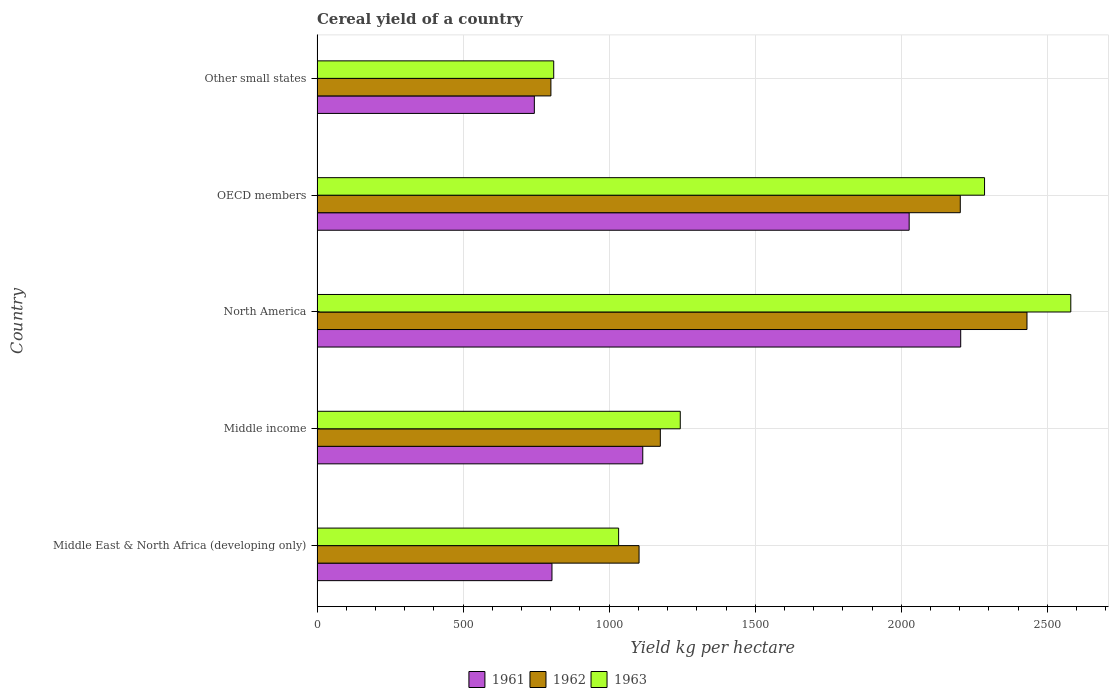How many different coloured bars are there?
Your answer should be compact. 3. How many groups of bars are there?
Your answer should be very brief. 5. Are the number of bars per tick equal to the number of legend labels?
Keep it short and to the point. Yes. Are the number of bars on each tick of the Y-axis equal?
Give a very brief answer. Yes. How many bars are there on the 2nd tick from the top?
Give a very brief answer. 3. How many bars are there on the 2nd tick from the bottom?
Your answer should be compact. 3. What is the total cereal yield in 1962 in Middle income?
Make the answer very short. 1175.1. Across all countries, what is the maximum total cereal yield in 1961?
Give a very brief answer. 2203.29. Across all countries, what is the minimum total cereal yield in 1962?
Provide a succinct answer. 800.53. In which country was the total cereal yield in 1962 maximum?
Offer a terse response. North America. In which country was the total cereal yield in 1961 minimum?
Make the answer very short. Other small states. What is the total total cereal yield in 1963 in the graph?
Your response must be concise. 7950.86. What is the difference between the total cereal yield in 1963 in Middle East & North Africa (developing only) and that in North America?
Ensure brevity in your answer.  -1547.89. What is the difference between the total cereal yield in 1963 in Other small states and the total cereal yield in 1961 in OECD members?
Your answer should be very brief. -1216.76. What is the average total cereal yield in 1963 per country?
Provide a short and direct response. 1590.17. What is the difference between the total cereal yield in 1962 and total cereal yield in 1961 in Other small states?
Provide a short and direct response. 56.73. What is the ratio of the total cereal yield in 1962 in Middle income to that in OECD members?
Give a very brief answer. 0.53. Is the total cereal yield in 1961 in OECD members less than that in Other small states?
Make the answer very short. No. What is the difference between the highest and the second highest total cereal yield in 1963?
Offer a very short reply. 295.28. What is the difference between the highest and the lowest total cereal yield in 1962?
Your answer should be compact. 1629.69. How many bars are there?
Make the answer very short. 15. Are all the bars in the graph horizontal?
Keep it short and to the point. Yes. How many countries are there in the graph?
Provide a succinct answer. 5. What is the difference between two consecutive major ticks on the X-axis?
Your answer should be very brief. 500. Are the values on the major ticks of X-axis written in scientific E-notation?
Ensure brevity in your answer.  No. How many legend labels are there?
Your answer should be compact. 3. How are the legend labels stacked?
Your answer should be very brief. Horizontal. What is the title of the graph?
Give a very brief answer. Cereal yield of a country. What is the label or title of the X-axis?
Your response must be concise. Yield kg per hectare. What is the Yield kg per hectare in 1961 in Middle East & North Africa (developing only)?
Provide a short and direct response. 804.16. What is the Yield kg per hectare of 1962 in Middle East & North Africa (developing only)?
Provide a short and direct response. 1102.28. What is the Yield kg per hectare of 1963 in Middle East & North Africa (developing only)?
Make the answer very short. 1032.31. What is the Yield kg per hectare of 1961 in Middle income?
Offer a very short reply. 1114.95. What is the Yield kg per hectare in 1962 in Middle income?
Your response must be concise. 1175.1. What is the Yield kg per hectare in 1963 in Middle income?
Provide a succinct answer. 1243.31. What is the Yield kg per hectare of 1961 in North America?
Your answer should be very brief. 2203.29. What is the Yield kg per hectare of 1962 in North America?
Offer a terse response. 2430.22. What is the Yield kg per hectare in 1963 in North America?
Make the answer very short. 2580.19. What is the Yield kg per hectare of 1961 in OECD members?
Keep it short and to the point. 2026.89. What is the Yield kg per hectare of 1962 in OECD members?
Give a very brief answer. 2201.88. What is the Yield kg per hectare in 1963 in OECD members?
Ensure brevity in your answer.  2284.91. What is the Yield kg per hectare in 1961 in Other small states?
Your answer should be very brief. 743.8. What is the Yield kg per hectare of 1962 in Other small states?
Your answer should be very brief. 800.53. What is the Yield kg per hectare in 1963 in Other small states?
Offer a very short reply. 810.13. Across all countries, what is the maximum Yield kg per hectare of 1961?
Offer a terse response. 2203.29. Across all countries, what is the maximum Yield kg per hectare in 1962?
Make the answer very short. 2430.22. Across all countries, what is the maximum Yield kg per hectare in 1963?
Your response must be concise. 2580.19. Across all countries, what is the minimum Yield kg per hectare in 1961?
Give a very brief answer. 743.8. Across all countries, what is the minimum Yield kg per hectare of 1962?
Give a very brief answer. 800.53. Across all countries, what is the minimum Yield kg per hectare of 1963?
Your response must be concise. 810.13. What is the total Yield kg per hectare of 1961 in the graph?
Keep it short and to the point. 6893.09. What is the total Yield kg per hectare of 1962 in the graph?
Ensure brevity in your answer.  7710.01. What is the total Yield kg per hectare of 1963 in the graph?
Ensure brevity in your answer.  7950.86. What is the difference between the Yield kg per hectare in 1961 in Middle East & North Africa (developing only) and that in Middle income?
Offer a terse response. -310.79. What is the difference between the Yield kg per hectare in 1962 in Middle East & North Africa (developing only) and that in Middle income?
Provide a succinct answer. -72.82. What is the difference between the Yield kg per hectare in 1963 in Middle East & North Africa (developing only) and that in Middle income?
Provide a short and direct response. -211. What is the difference between the Yield kg per hectare in 1961 in Middle East & North Africa (developing only) and that in North America?
Your response must be concise. -1399.14. What is the difference between the Yield kg per hectare of 1962 in Middle East & North Africa (developing only) and that in North America?
Your response must be concise. -1327.94. What is the difference between the Yield kg per hectare in 1963 in Middle East & North Africa (developing only) and that in North America?
Your answer should be compact. -1547.89. What is the difference between the Yield kg per hectare of 1961 in Middle East & North Africa (developing only) and that in OECD members?
Your answer should be very brief. -1222.73. What is the difference between the Yield kg per hectare of 1962 in Middle East & North Africa (developing only) and that in OECD members?
Ensure brevity in your answer.  -1099.6. What is the difference between the Yield kg per hectare of 1963 in Middle East & North Africa (developing only) and that in OECD members?
Your answer should be compact. -1252.61. What is the difference between the Yield kg per hectare in 1961 in Middle East & North Africa (developing only) and that in Other small states?
Make the answer very short. 60.36. What is the difference between the Yield kg per hectare in 1962 in Middle East & North Africa (developing only) and that in Other small states?
Your answer should be very brief. 301.75. What is the difference between the Yield kg per hectare of 1963 in Middle East & North Africa (developing only) and that in Other small states?
Ensure brevity in your answer.  222.18. What is the difference between the Yield kg per hectare of 1961 in Middle income and that in North America?
Make the answer very short. -1088.35. What is the difference between the Yield kg per hectare of 1962 in Middle income and that in North America?
Your answer should be compact. -1255.12. What is the difference between the Yield kg per hectare in 1963 in Middle income and that in North America?
Give a very brief answer. -1336.88. What is the difference between the Yield kg per hectare of 1961 in Middle income and that in OECD members?
Offer a terse response. -911.94. What is the difference between the Yield kg per hectare in 1962 in Middle income and that in OECD members?
Make the answer very short. -1026.78. What is the difference between the Yield kg per hectare of 1963 in Middle income and that in OECD members?
Your answer should be compact. -1041.6. What is the difference between the Yield kg per hectare in 1961 in Middle income and that in Other small states?
Your response must be concise. 371.14. What is the difference between the Yield kg per hectare in 1962 in Middle income and that in Other small states?
Your answer should be very brief. 374.57. What is the difference between the Yield kg per hectare in 1963 in Middle income and that in Other small states?
Offer a very short reply. 433.18. What is the difference between the Yield kg per hectare in 1961 in North America and that in OECD members?
Keep it short and to the point. 176.41. What is the difference between the Yield kg per hectare of 1962 in North America and that in OECD members?
Provide a succinct answer. 228.34. What is the difference between the Yield kg per hectare in 1963 in North America and that in OECD members?
Ensure brevity in your answer.  295.28. What is the difference between the Yield kg per hectare of 1961 in North America and that in Other small states?
Your response must be concise. 1459.49. What is the difference between the Yield kg per hectare of 1962 in North America and that in Other small states?
Provide a succinct answer. 1629.69. What is the difference between the Yield kg per hectare in 1963 in North America and that in Other small states?
Your answer should be compact. 1770.06. What is the difference between the Yield kg per hectare in 1961 in OECD members and that in Other small states?
Make the answer very short. 1283.09. What is the difference between the Yield kg per hectare in 1962 in OECD members and that in Other small states?
Your response must be concise. 1401.35. What is the difference between the Yield kg per hectare of 1963 in OECD members and that in Other small states?
Offer a very short reply. 1474.78. What is the difference between the Yield kg per hectare in 1961 in Middle East & North Africa (developing only) and the Yield kg per hectare in 1962 in Middle income?
Provide a succinct answer. -370.94. What is the difference between the Yield kg per hectare of 1961 in Middle East & North Africa (developing only) and the Yield kg per hectare of 1963 in Middle income?
Ensure brevity in your answer.  -439.15. What is the difference between the Yield kg per hectare in 1962 in Middle East & North Africa (developing only) and the Yield kg per hectare in 1963 in Middle income?
Your answer should be compact. -141.03. What is the difference between the Yield kg per hectare of 1961 in Middle East & North Africa (developing only) and the Yield kg per hectare of 1962 in North America?
Provide a succinct answer. -1626.06. What is the difference between the Yield kg per hectare in 1961 in Middle East & North Africa (developing only) and the Yield kg per hectare in 1963 in North America?
Offer a terse response. -1776.04. What is the difference between the Yield kg per hectare in 1962 in Middle East & North Africa (developing only) and the Yield kg per hectare in 1963 in North America?
Your answer should be compact. -1477.91. What is the difference between the Yield kg per hectare of 1961 in Middle East & North Africa (developing only) and the Yield kg per hectare of 1962 in OECD members?
Offer a terse response. -1397.72. What is the difference between the Yield kg per hectare of 1961 in Middle East & North Africa (developing only) and the Yield kg per hectare of 1963 in OECD members?
Give a very brief answer. -1480.76. What is the difference between the Yield kg per hectare in 1962 in Middle East & North Africa (developing only) and the Yield kg per hectare in 1963 in OECD members?
Offer a very short reply. -1182.63. What is the difference between the Yield kg per hectare in 1961 in Middle East & North Africa (developing only) and the Yield kg per hectare in 1962 in Other small states?
Your answer should be compact. 3.63. What is the difference between the Yield kg per hectare in 1961 in Middle East & North Africa (developing only) and the Yield kg per hectare in 1963 in Other small states?
Provide a succinct answer. -5.97. What is the difference between the Yield kg per hectare of 1962 in Middle East & North Africa (developing only) and the Yield kg per hectare of 1963 in Other small states?
Offer a very short reply. 292.15. What is the difference between the Yield kg per hectare in 1961 in Middle income and the Yield kg per hectare in 1962 in North America?
Provide a short and direct response. -1315.27. What is the difference between the Yield kg per hectare of 1961 in Middle income and the Yield kg per hectare of 1963 in North America?
Offer a very short reply. -1465.25. What is the difference between the Yield kg per hectare in 1962 in Middle income and the Yield kg per hectare in 1963 in North America?
Your answer should be very brief. -1405.09. What is the difference between the Yield kg per hectare of 1961 in Middle income and the Yield kg per hectare of 1962 in OECD members?
Offer a terse response. -1086.93. What is the difference between the Yield kg per hectare of 1961 in Middle income and the Yield kg per hectare of 1963 in OECD members?
Provide a short and direct response. -1169.97. What is the difference between the Yield kg per hectare of 1962 in Middle income and the Yield kg per hectare of 1963 in OECD members?
Ensure brevity in your answer.  -1109.81. What is the difference between the Yield kg per hectare of 1961 in Middle income and the Yield kg per hectare of 1962 in Other small states?
Offer a very short reply. 314.41. What is the difference between the Yield kg per hectare of 1961 in Middle income and the Yield kg per hectare of 1963 in Other small states?
Give a very brief answer. 304.82. What is the difference between the Yield kg per hectare of 1962 in Middle income and the Yield kg per hectare of 1963 in Other small states?
Keep it short and to the point. 364.97. What is the difference between the Yield kg per hectare in 1961 in North America and the Yield kg per hectare in 1962 in OECD members?
Your answer should be compact. 1.41. What is the difference between the Yield kg per hectare in 1961 in North America and the Yield kg per hectare in 1963 in OECD members?
Offer a very short reply. -81.62. What is the difference between the Yield kg per hectare in 1962 in North America and the Yield kg per hectare in 1963 in OECD members?
Provide a short and direct response. 145.3. What is the difference between the Yield kg per hectare in 1961 in North America and the Yield kg per hectare in 1962 in Other small states?
Your answer should be very brief. 1402.76. What is the difference between the Yield kg per hectare in 1961 in North America and the Yield kg per hectare in 1963 in Other small states?
Offer a very short reply. 1393.16. What is the difference between the Yield kg per hectare in 1962 in North America and the Yield kg per hectare in 1963 in Other small states?
Offer a terse response. 1620.09. What is the difference between the Yield kg per hectare in 1961 in OECD members and the Yield kg per hectare in 1962 in Other small states?
Your answer should be very brief. 1226.36. What is the difference between the Yield kg per hectare in 1961 in OECD members and the Yield kg per hectare in 1963 in Other small states?
Keep it short and to the point. 1216.76. What is the difference between the Yield kg per hectare in 1962 in OECD members and the Yield kg per hectare in 1963 in Other small states?
Keep it short and to the point. 1391.75. What is the average Yield kg per hectare in 1961 per country?
Provide a succinct answer. 1378.62. What is the average Yield kg per hectare in 1962 per country?
Your answer should be very brief. 1542. What is the average Yield kg per hectare of 1963 per country?
Your answer should be very brief. 1590.17. What is the difference between the Yield kg per hectare of 1961 and Yield kg per hectare of 1962 in Middle East & North Africa (developing only)?
Provide a succinct answer. -298.12. What is the difference between the Yield kg per hectare in 1961 and Yield kg per hectare in 1963 in Middle East & North Africa (developing only)?
Keep it short and to the point. -228.15. What is the difference between the Yield kg per hectare of 1962 and Yield kg per hectare of 1963 in Middle East & North Africa (developing only)?
Ensure brevity in your answer.  69.97. What is the difference between the Yield kg per hectare in 1961 and Yield kg per hectare in 1962 in Middle income?
Make the answer very short. -60.15. What is the difference between the Yield kg per hectare of 1961 and Yield kg per hectare of 1963 in Middle income?
Your answer should be very brief. -128.37. What is the difference between the Yield kg per hectare of 1962 and Yield kg per hectare of 1963 in Middle income?
Your response must be concise. -68.21. What is the difference between the Yield kg per hectare in 1961 and Yield kg per hectare in 1962 in North America?
Offer a very short reply. -226.92. What is the difference between the Yield kg per hectare in 1961 and Yield kg per hectare in 1963 in North America?
Keep it short and to the point. -376.9. What is the difference between the Yield kg per hectare of 1962 and Yield kg per hectare of 1963 in North America?
Provide a short and direct response. -149.98. What is the difference between the Yield kg per hectare in 1961 and Yield kg per hectare in 1962 in OECD members?
Ensure brevity in your answer.  -174.99. What is the difference between the Yield kg per hectare of 1961 and Yield kg per hectare of 1963 in OECD members?
Keep it short and to the point. -258.03. What is the difference between the Yield kg per hectare in 1962 and Yield kg per hectare in 1963 in OECD members?
Provide a succinct answer. -83.03. What is the difference between the Yield kg per hectare in 1961 and Yield kg per hectare in 1962 in Other small states?
Offer a terse response. -56.73. What is the difference between the Yield kg per hectare of 1961 and Yield kg per hectare of 1963 in Other small states?
Offer a very short reply. -66.33. What is the difference between the Yield kg per hectare in 1962 and Yield kg per hectare in 1963 in Other small states?
Provide a short and direct response. -9.6. What is the ratio of the Yield kg per hectare of 1961 in Middle East & North Africa (developing only) to that in Middle income?
Your answer should be compact. 0.72. What is the ratio of the Yield kg per hectare in 1962 in Middle East & North Africa (developing only) to that in Middle income?
Offer a terse response. 0.94. What is the ratio of the Yield kg per hectare of 1963 in Middle East & North Africa (developing only) to that in Middle income?
Your answer should be compact. 0.83. What is the ratio of the Yield kg per hectare of 1961 in Middle East & North Africa (developing only) to that in North America?
Your answer should be compact. 0.36. What is the ratio of the Yield kg per hectare in 1962 in Middle East & North Africa (developing only) to that in North America?
Give a very brief answer. 0.45. What is the ratio of the Yield kg per hectare in 1963 in Middle East & North Africa (developing only) to that in North America?
Your answer should be very brief. 0.4. What is the ratio of the Yield kg per hectare of 1961 in Middle East & North Africa (developing only) to that in OECD members?
Keep it short and to the point. 0.4. What is the ratio of the Yield kg per hectare in 1962 in Middle East & North Africa (developing only) to that in OECD members?
Give a very brief answer. 0.5. What is the ratio of the Yield kg per hectare in 1963 in Middle East & North Africa (developing only) to that in OECD members?
Your answer should be compact. 0.45. What is the ratio of the Yield kg per hectare of 1961 in Middle East & North Africa (developing only) to that in Other small states?
Your answer should be compact. 1.08. What is the ratio of the Yield kg per hectare of 1962 in Middle East & North Africa (developing only) to that in Other small states?
Keep it short and to the point. 1.38. What is the ratio of the Yield kg per hectare in 1963 in Middle East & North Africa (developing only) to that in Other small states?
Provide a succinct answer. 1.27. What is the ratio of the Yield kg per hectare in 1961 in Middle income to that in North America?
Keep it short and to the point. 0.51. What is the ratio of the Yield kg per hectare in 1962 in Middle income to that in North America?
Provide a short and direct response. 0.48. What is the ratio of the Yield kg per hectare in 1963 in Middle income to that in North America?
Your answer should be very brief. 0.48. What is the ratio of the Yield kg per hectare of 1961 in Middle income to that in OECD members?
Your response must be concise. 0.55. What is the ratio of the Yield kg per hectare in 1962 in Middle income to that in OECD members?
Your answer should be compact. 0.53. What is the ratio of the Yield kg per hectare in 1963 in Middle income to that in OECD members?
Provide a succinct answer. 0.54. What is the ratio of the Yield kg per hectare of 1961 in Middle income to that in Other small states?
Provide a short and direct response. 1.5. What is the ratio of the Yield kg per hectare in 1962 in Middle income to that in Other small states?
Your response must be concise. 1.47. What is the ratio of the Yield kg per hectare in 1963 in Middle income to that in Other small states?
Your response must be concise. 1.53. What is the ratio of the Yield kg per hectare of 1961 in North America to that in OECD members?
Give a very brief answer. 1.09. What is the ratio of the Yield kg per hectare in 1962 in North America to that in OECD members?
Make the answer very short. 1.1. What is the ratio of the Yield kg per hectare in 1963 in North America to that in OECD members?
Ensure brevity in your answer.  1.13. What is the ratio of the Yield kg per hectare of 1961 in North America to that in Other small states?
Your response must be concise. 2.96. What is the ratio of the Yield kg per hectare of 1962 in North America to that in Other small states?
Keep it short and to the point. 3.04. What is the ratio of the Yield kg per hectare in 1963 in North America to that in Other small states?
Keep it short and to the point. 3.18. What is the ratio of the Yield kg per hectare in 1961 in OECD members to that in Other small states?
Offer a very short reply. 2.73. What is the ratio of the Yield kg per hectare of 1962 in OECD members to that in Other small states?
Provide a succinct answer. 2.75. What is the ratio of the Yield kg per hectare of 1963 in OECD members to that in Other small states?
Your answer should be compact. 2.82. What is the difference between the highest and the second highest Yield kg per hectare in 1961?
Make the answer very short. 176.41. What is the difference between the highest and the second highest Yield kg per hectare of 1962?
Ensure brevity in your answer.  228.34. What is the difference between the highest and the second highest Yield kg per hectare in 1963?
Offer a terse response. 295.28. What is the difference between the highest and the lowest Yield kg per hectare of 1961?
Give a very brief answer. 1459.49. What is the difference between the highest and the lowest Yield kg per hectare of 1962?
Make the answer very short. 1629.69. What is the difference between the highest and the lowest Yield kg per hectare of 1963?
Provide a short and direct response. 1770.06. 